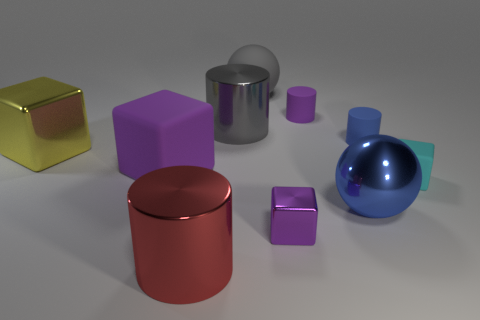Subtract all spheres. How many objects are left? 8 Add 3 big blue metallic objects. How many big blue metallic objects exist? 4 Subtract 1 blue balls. How many objects are left? 9 Subtract all small blue cylinders. Subtract all big blue matte spheres. How many objects are left? 9 Add 7 small cyan matte things. How many small cyan matte things are left? 8 